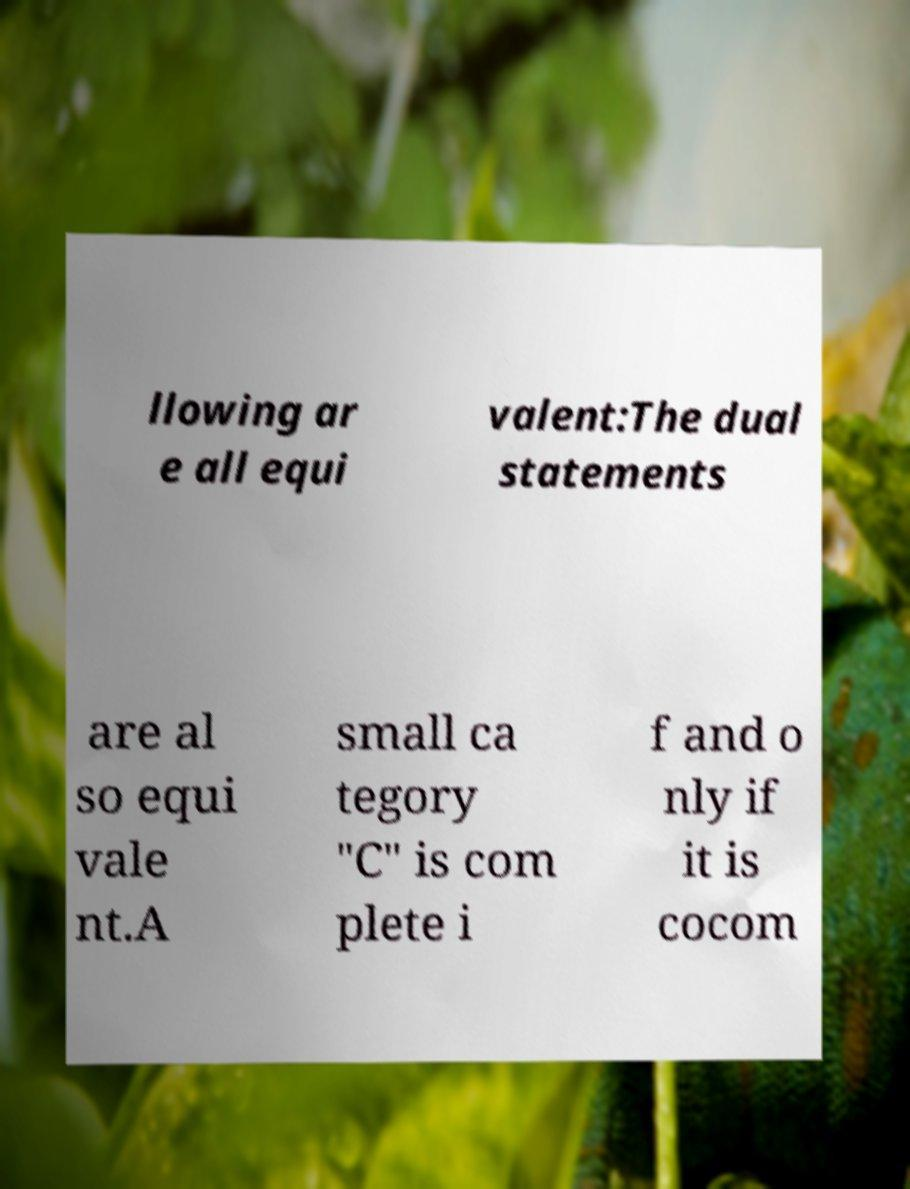Can you accurately transcribe the text from the provided image for me? llowing ar e all equi valent:The dual statements are al so equi vale nt.A small ca tegory "C" is com plete i f and o nly if it is cocom 